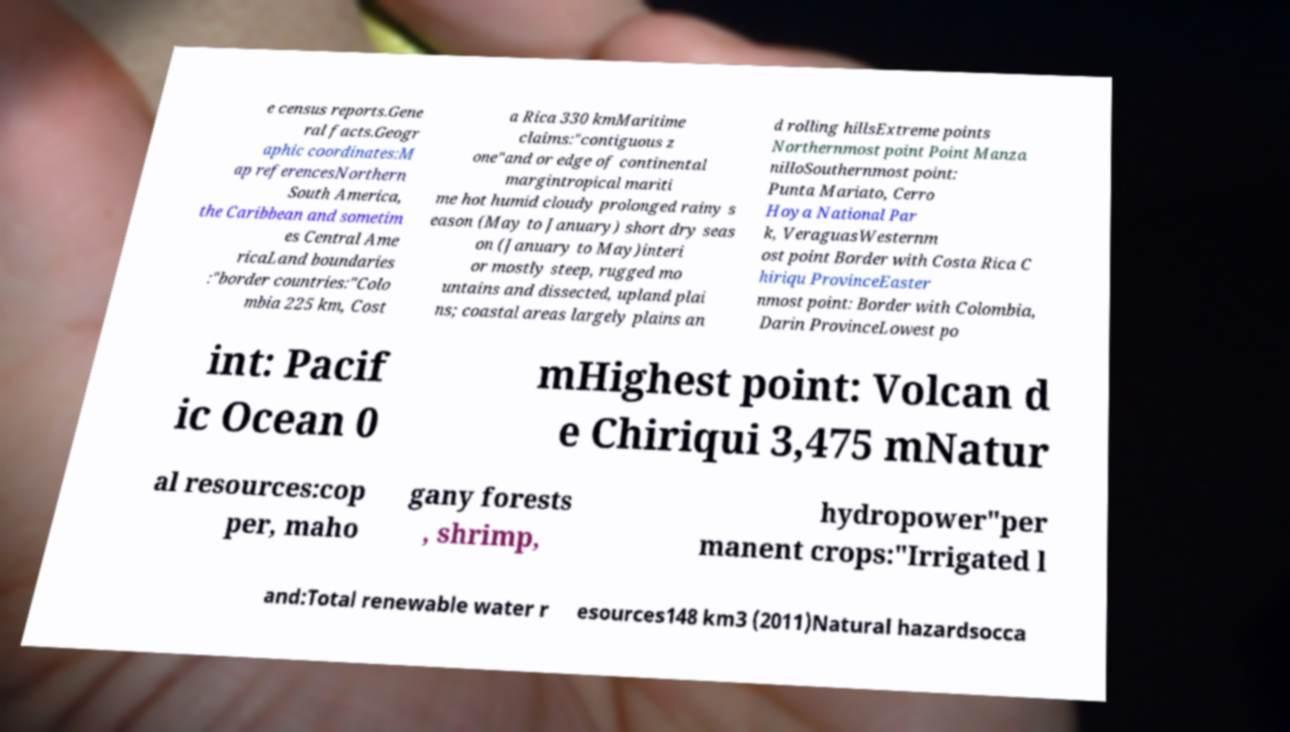Please identify and transcribe the text found in this image. e census reports.Gene ral facts.Geogr aphic coordinates:M ap referencesNorthern South America, the Caribbean and sometim es Central Ame ricaLand boundaries :"border countries:"Colo mbia 225 km, Cost a Rica 330 kmMaritime claims:"contiguous z one"and or edge of continental margintropical mariti me hot humid cloudy prolonged rainy s eason (May to January) short dry seas on (January to May)interi or mostly steep, rugged mo untains and dissected, upland plai ns; coastal areas largely plains an d rolling hillsExtreme points Northernmost point Point Manza nilloSouthernmost point: Punta Mariato, Cerro Hoya National Par k, VeraguasWesternm ost point Border with Costa Rica C hiriqu ProvinceEaster nmost point: Border with Colombia, Darin ProvinceLowest po int: Pacif ic Ocean 0 mHighest point: Volcan d e Chiriqui 3,475 mNatur al resources:cop per, maho gany forests , shrimp, hydropower"per manent crops:"Irrigated l and:Total renewable water r esources148 km3 (2011)Natural hazardsocca 